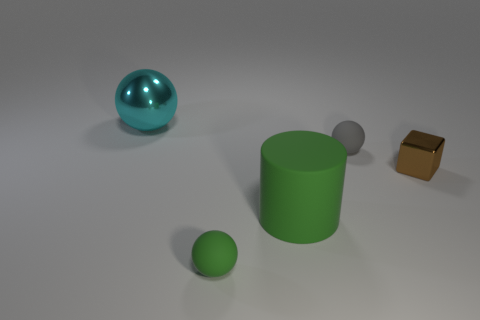What is the relative size of the green cylindrical object compared to the other objects? The green cylindrical object is the second largest in the scene. It is smaller than the teal sphere, larger than the silver sphere, and both are far larger than the golden brown cube, which is the smallest object in the image. 